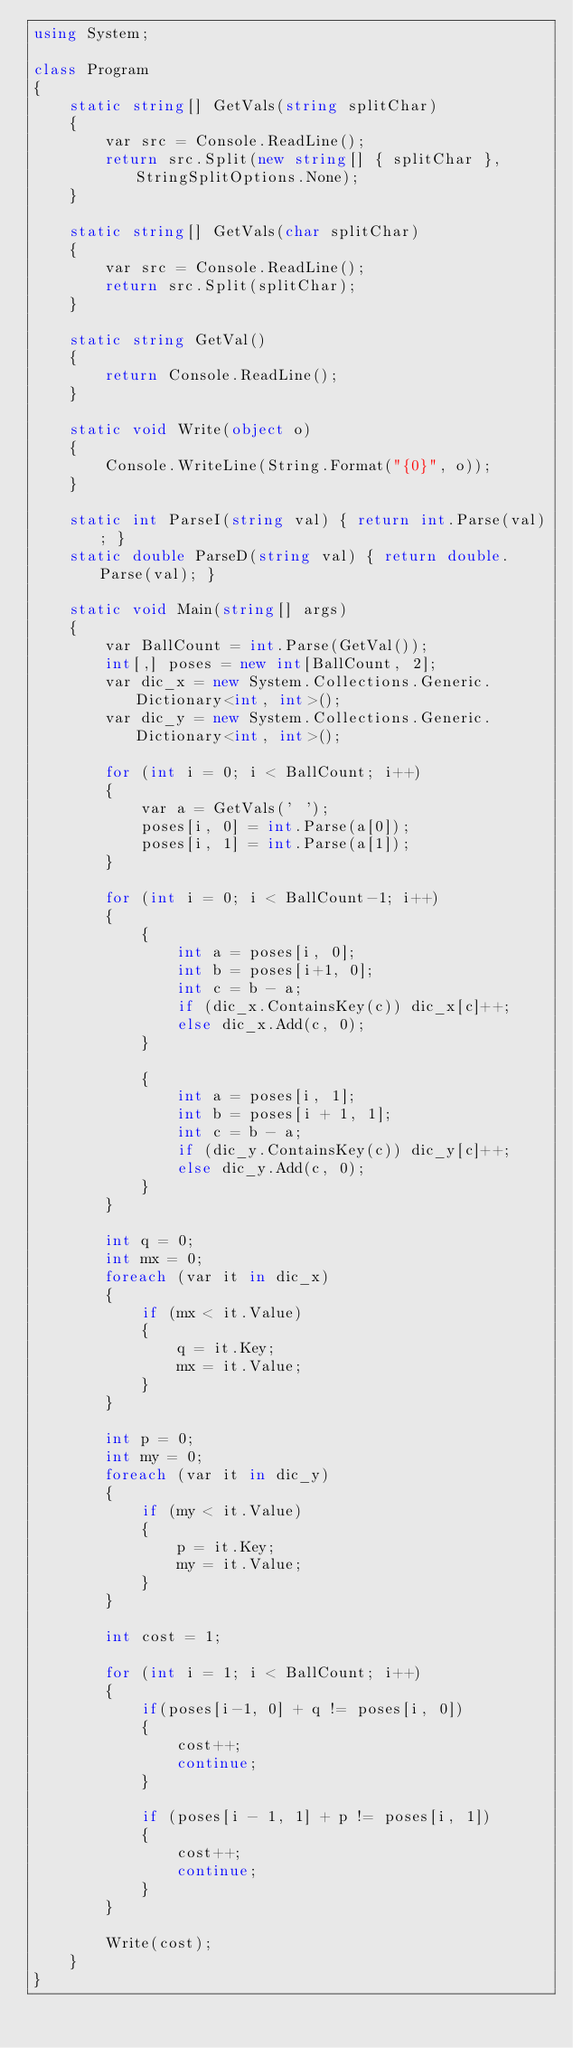<code> <loc_0><loc_0><loc_500><loc_500><_C#_>using System;

class Program
{
    static string[] GetVals(string splitChar)
    {
        var src = Console.ReadLine();
        return src.Split(new string[] { splitChar }, StringSplitOptions.None);
    }

    static string[] GetVals(char splitChar)
    {
        var src = Console.ReadLine();
        return src.Split(splitChar);
    }

    static string GetVal()
    {
        return Console.ReadLine();
    }

    static void Write(object o)
    {
        Console.WriteLine(String.Format("{0}", o));
    }

    static int ParseI(string val) { return int.Parse(val); }
    static double ParseD(string val) { return double.Parse(val); }

    static void Main(string[] args)
    {
        var BallCount = int.Parse(GetVal());
        int[,] poses = new int[BallCount, 2];
        var dic_x = new System.Collections.Generic.Dictionary<int, int>();
        var dic_y = new System.Collections.Generic.Dictionary<int, int>();

        for (int i = 0; i < BallCount; i++)
        {
            var a = GetVals(' ');
            poses[i, 0] = int.Parse(a[0]);
            poses[i, 1] = int.Parse(a[1]);
        }

        for (int i = 0; i < BallCount-1; i++)
        {
            {
                int a = poses[i, 0];
                int b = poses[i+1, 0];
                int c = b - a;
                if (dic_x.ContainsKey(c)) dic_x[c]++;
                else dic_x.Add(c, 0);
            }

            {
                int a = poses[i, 1];
                int b = poses[i + 1, 1];
                int c = b - a;
                if (dic_y.ContainsKey(c)) dic_y[c]++;
                else dic_y.Add(c, 0);
            }
        }

        int q = 0;
        int mx = 0;
        foreach (var it in dic_x)
        {
            if (mx < it.Value)
            {
                q = it.Key;
                mx = it.Value;
            }
        }

        int p = 0;
        int my = 0;
        foreach (var it in dic_y)
        {
            if (my < it.Value)
            {
                p = it.Key;
                my = it.Value;
            }
        }

        int cost = 1;

        for (int i = 1; i < BallCount; i++)
        {
            if(poses[i-1, 0] + q != poses[i, 0])
            {
                cost++;
                continue;
            }

            if (poses[i - 1, 1] + p != poses[i, 1])
            {
                cost++;
                continue;
            }
        }

        Write(cost);
    }
}</code> 